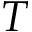Convert formula to latex. <formula><loc_0><loc_0><loc_500><loc_500>T</formula> 